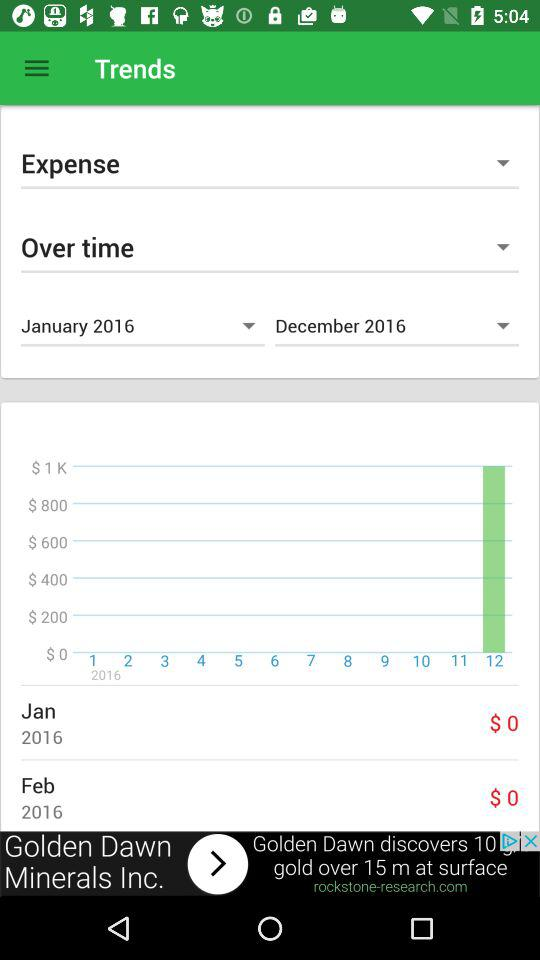What is the expense in February, 2016? The expense is $0. 